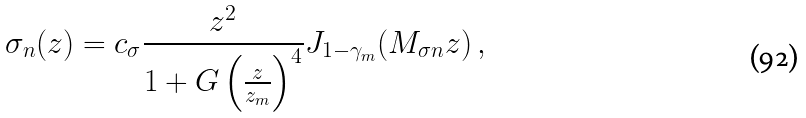Convert formula to latex. <formula><loc_0><loc_0><loc_500><loc_500>\sigma _ { n } ( z ) = c _ { \sigma } \frac { z ^ { 2 } } { 1 + G \left ( \frac { z } { z _ { m } } \right ) ^ { 4 } } J _ { 1 - \gamma _ { m } } ( M _ { \sigma n } z ) \, ,</formula> 